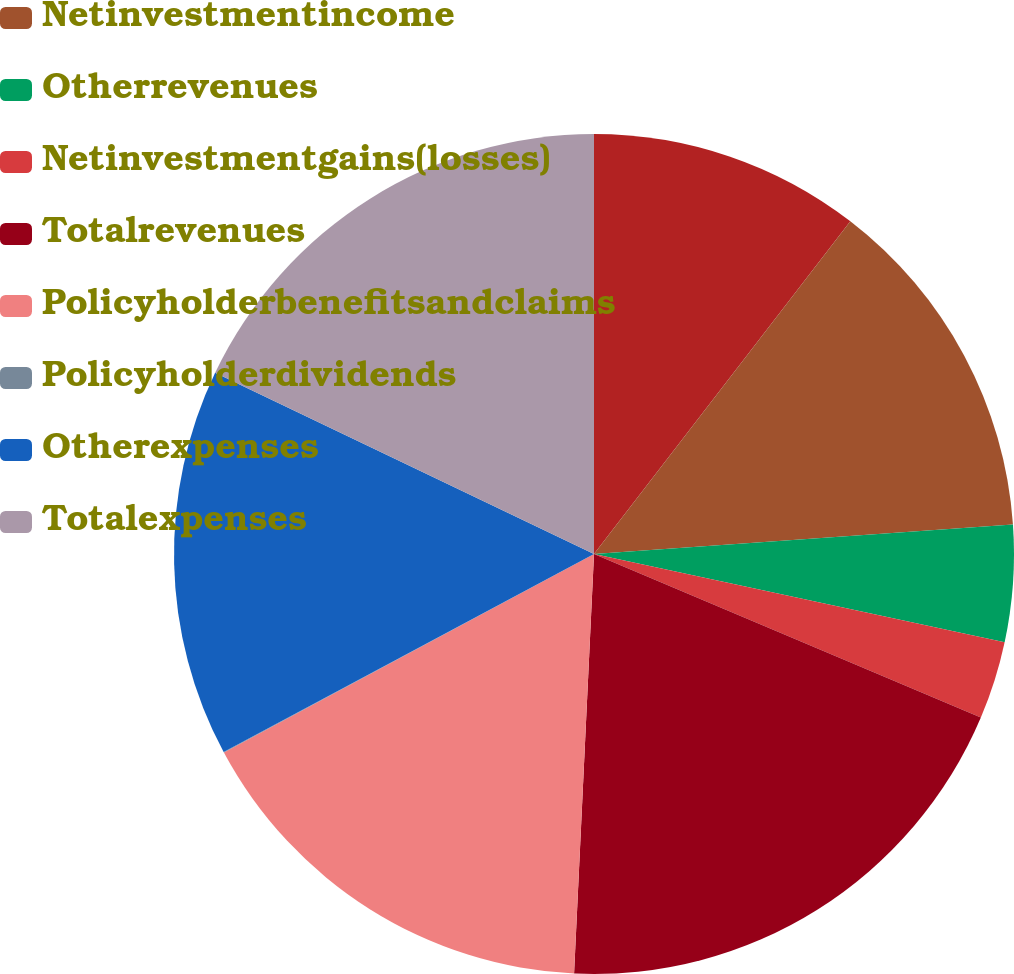Convert chart. <chart><loc_0><loc_0><loc_500><loc_500><pie_chart><ecel><fcel>Netinvestmentincome<fcel>Otherrevenues<fcel>Netinvestmentgains(losses)<fcel>Totalrevenues<fcel>Policyholderbenefitsandclaims<fcel>Policyholderdividends<fcel>Otherexpenses<fcel>Totalexpenses<nl><fcel>10.45%<fcel>13.43%<fcel>4.49%<fcel>3.0%<fcel>19.39%<fcel>16.41%<fcel>0.02%<fcel>14.92%<fcel>17.9%<nl></chart> 